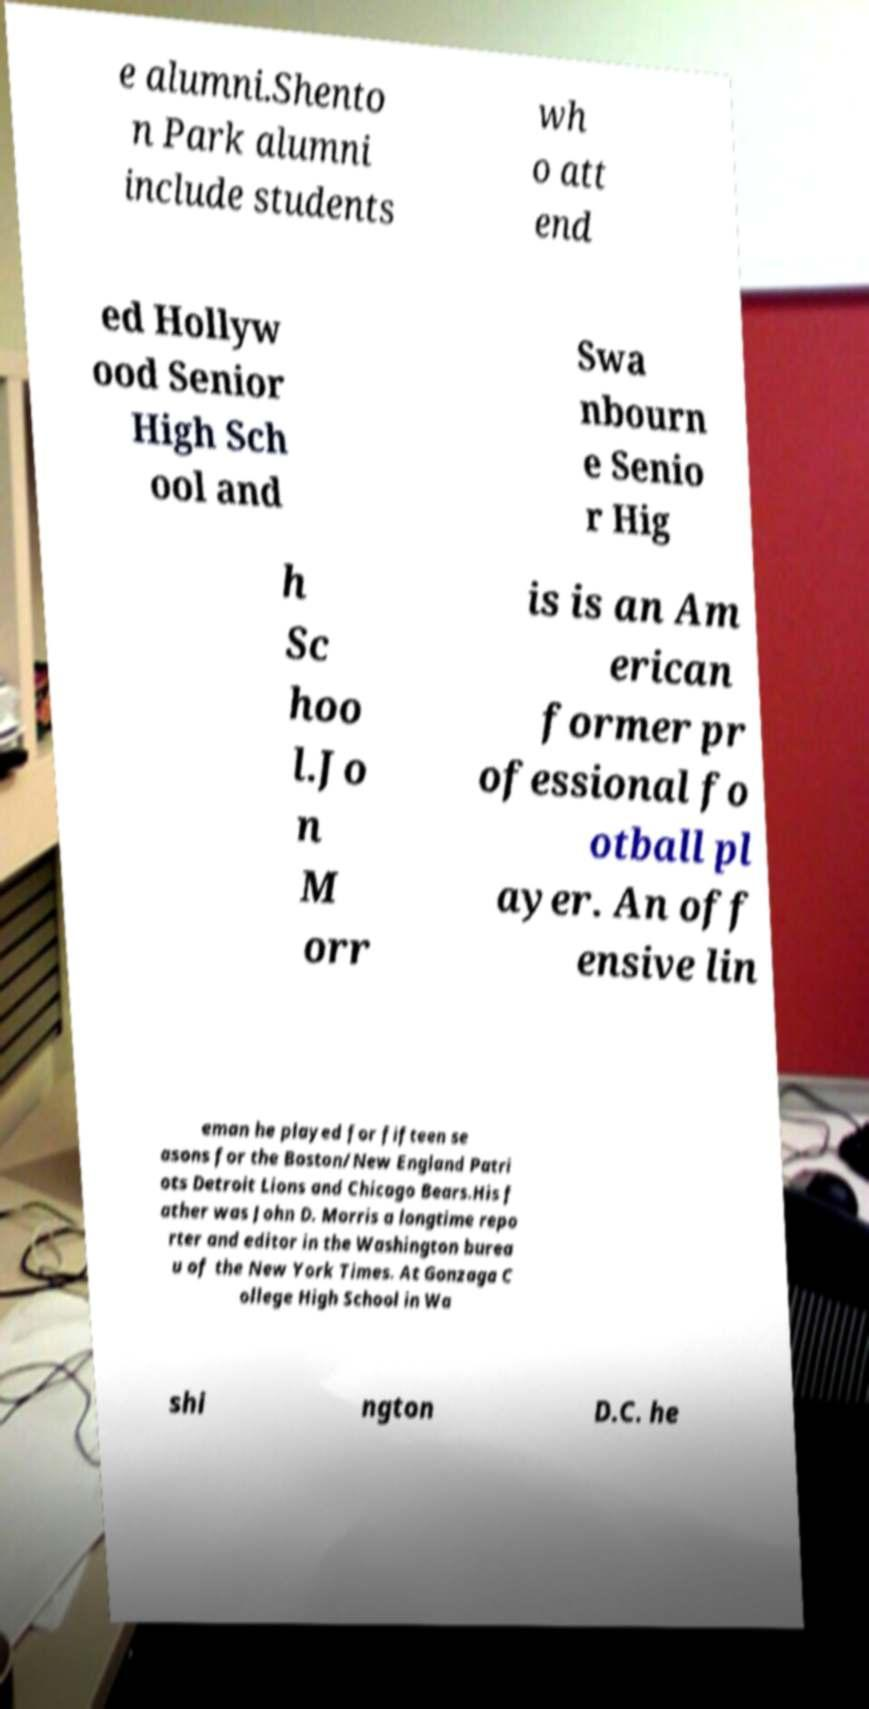Please identify and transcribe the text found in this image. e alumni.Shento n Park alumni include students wh o att end ed Hollyw ood Senior High Sch ool and Swa nbourn e Senio r Hig h Sc hoo l.Jo n M orr is is an Am erican former pr ofessional fo otball pl ayer. An off ensive lin eman he played for fifteen se asons for the Boston/New England Patri ots Detroit Lions and Chicago Bears.His f ather was John D. Morris a longtime repo rter and editor in the Washington burea u of the New York Times. At Gonzaga C ollege High School in Wa shi ngton D.C. he 